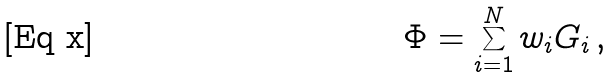<formula> <loc_0><loc_0><loc_500><loc_500>\Phi = \sum _ { i = 1 } ^ { N } w _ { i } G _ { i } \, ,</formula> 